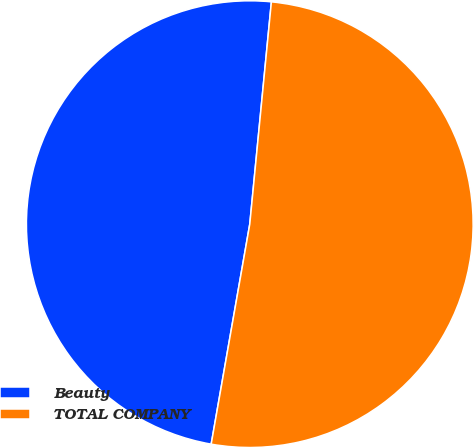Convert chart. <chart><loc_0><loc_0><loc_500><loc_500><pie_chart><fcel>Beauty<fcel>TOTAL COMPANY<nl><fcel>48.78%<fcel>51.22%<nl></chart> 